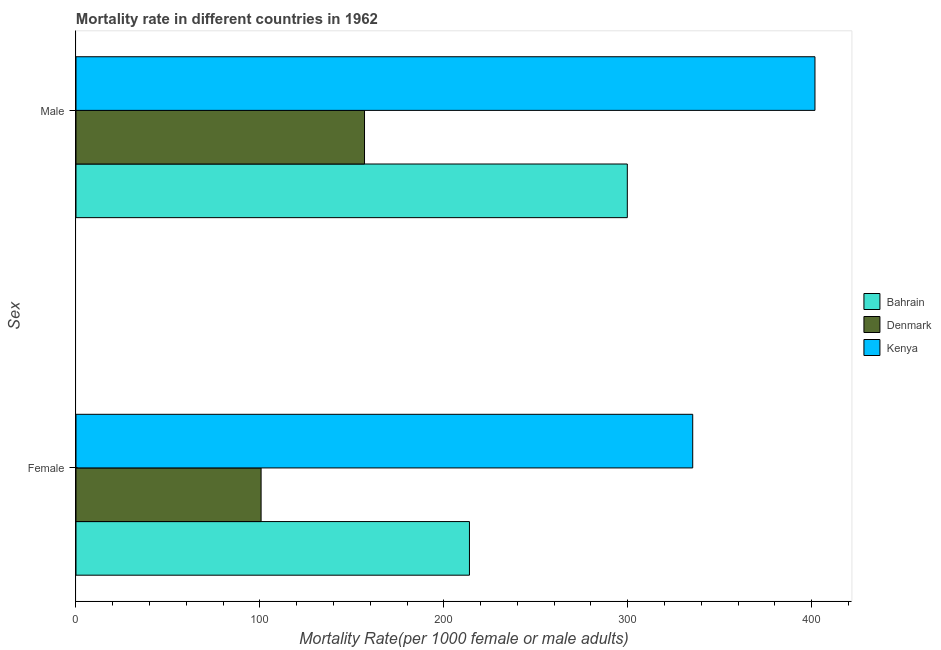Are the number of bars on each tick of the Y-axis equal?
Offer a very short reply. Yes. How many bars are there on the 2nd tick from the top?
Ensure brevity in your answer.  3. How many bars are there on the 1st tick from the bottom?
Offer a terse response. 3. What is the male mortality rate in Bahrain?
Keep it short and to the point. 299.81. Across all countries, what is the maximum male mortality rate?
Keep it short and to the point. 401.86. Across all countries, what is the minimum male mortality rate?
Your response must be concise. 156.9. In which country was the female mortality rate maximum?
Give a very brief answer. Kenya. What is the total female mortality rate in the graph?
Your answer should be compact. 650.01. What is the difference between the female mortality rate in Bahrain and that in Denmark?
Make the answer very short. 113.31. What is the difference between the female mortality rate in Denmark and the male mortality rate in Kenya?
Offer a very short reply. -301.2. What is the average male mortality rate per country?
Your response must be concise. 286.19. What is the difference between the female mortality rate and male mortality rate in Bahrain?
Offer a terse response. -85.84. In how many countries, is the female mortality rate greater than 80 ?
Your answer should be compact. 3. What is the ratio of the male mortality rate in Denmark to that in Bahrain?
Give a very brief answer. 0.52. What does the 1st bar from the top in Female represents?
Offer a terse response. Kenya. What does the 3rd bar from the bottom in Female represents?
Offer a very short reply. Kenya. How many countries are there in the graph?
Your answer should be very brief. 3. Are the values on the major ticks of X-axis written in scientific E-notation?
Provide a succinct answer. No. Does the graph contain any zero values?
Offer a very short reply. No. Where does the legend appear in the graph?
Keep it short and to the point. Center right. How many legend labels are there?
Provide a succinct answer. 3. What is the title of the graph?
Provide a short and direct response. Mortality rate in different countries in 1962. What is the label or title of the X-axis?
Offer a very short reply. Mortality Rate(per 1000 female or male adults). What is the label or title of the Y-axis?
Your answer should be very brief. Sex. What is the Mortality Rate(per 1000 female or male adults) in Bahrain in Female?
Your answer should be very brief. 213.97. What is the Mortality Rate(per 1000 female or male adults) in Denmark in Female?
Provide a short and direct response. 100.66. What is the Mortality Rate(per 1000 female or male adults) in Kenya in Female?
Make the answer very short. 335.38. What is the Mortality Rate(per 1000 female or male adults) of Bahrain in Male?
Provide a succinct answer. 299.81. What is the Mortality Rate(per 1000 female or male adults) in Denmark in Male?
Your answer should be compact. 156.9. What is the Mortality Rate(per 1000 female or male adults) in Kenya in Male?
Make the answer very short. 401.86. Across all Sex, what is the maximum Mortality Rate(per 1000 female or male adults) in Bahrain?
Your answer should be very brief. 299.81. Across all Sex, what is the maximum Mortality Rate(per 1000 female or male adults) of Denmark?
Offer a very short reply. 156.9. Across all Sex, what is the maximum Mortality Rate(per 1000 female or male adults) of Kenya?
Offer a terse response. 401.86. Across all Sex, what is the minimum Mortality Rate(per 1000 female or male adults) of Bahrain?
Your answer should be compact. 213.97. Across all Sex, what is the minimum Mortality Rate(per 1000 female or male adults) of Denmark?
Offer a very short reply. 100.66. Across all Sex, what is the minimum Mortality Rate(per 1000 female or male adults) in Kenya?
Make the answer very short. 335.38. What is the total Mortality Rate(per 1000 female or male adults) of Bahrain in the graph?
Your answer should be compact. 513.78. What is the total Mortality Rate(per 1000 female or male adults) in Denmark in the graph?
Offer a very short reply. 257.56. What is the total Mortality Rate(per 1000 female or male adults) in Kenya in the graph?
Your answer should be compact. 737.24. What is the difference between the Mortality Rate(per 1000 female or male adults) of Bahrain in Female and that in Male?
Keep it short and to the point. -85.84. What is the difference between the Mortality Rate(per 1000 female or male adults) in Denmark in Female and that in Male?
Ensure brevity in your answer.  -56.24. What is the difference between the Mortality Rate(per 1000 female or male adults) of Kenya in Female and that in Male?
Ensure brevity in your answer.  -66.48. What is the difference between the Mortality Rate(per 1000 female or male adults) in Bahrain in Female and the Mortality Rate(per 1000 female or male adults) in Denmark in Male?
Your answer should be very brief. 57.07. What is the difference between the Mortality Rate(per 1000 female or male adults) in Bahrain in Female and the Mortality Rate(per 1000 female or male adults) in Kenya in Male?
Offer a terse response. -187.89. What is the difference between the Mortality Rate(per 1000 female or male adults) of Denmark in Female and the Mortality Rate(per 1000 female or male adults) of Kenya in Male?
Your answer should be compact. -301.2. What is the average Mortality Rate(per 1000 female or male adults) in Bahrain per Sex?
Ensure brevity in your answer.  256.89. What is the average Mortality Rate(per 1000 female or male adults) in Denmark per Sex?
Your answer should be compact. 128.78. What is the average Mortality Rate(per 1000 female or male adults) of Kenya per Sex?
Your answer should be very brief. 368.62. What is the difference between the Mortality Rate(per 1000 female or male adults) in Bahrain and Mortality Rate(per 1000 female or male adults) in Denmark in Female?
Your answer should be compact. 113.31. What is the difference between the Mortality Rate(per 1000 female or male adults) in Bahrain and Mortality Rate(per 1000 female or male adults) in Kenya in Female?
Offer a terse response. -121.41. What is the difference between the Mortality Rate(per 1000 female or male adults) in Denmark and Mortality Rate(per 1000 female or male adults) in Kenya in Female?
Keep it short and to the point. -234.72. What is the difference between the Mortality Rate(per 1000 female or male adults) of Bahrain and Mortality Rate(per 1000 female or male adults) of Denmark in Male?
Ensure brevity in your answer.  142.91. What is the difference between the Mortality Rate(per 1000 female or male adults) in Bahrain and Mortality Rate(per 1000 female or male adults) in Kenya in Male?
Provide a short and direct response. -102.05. What is the difference between the Mortality Rate(per 1000 female or male adults) of Denmark and Mortality Rate(per 1000 female or male adults) of Kenya in Male?
Keep it short and to the point. -244.96. What is the ratio of the Mortality Rate(per 1000 female or male adults) of Bahrain in Female to that in Male?
Keep it short and to the point. 0.71. What is the ratio of the Mortality Rate(per 1000 female or male adults) of Denmark in Female to that in Male?
Provide a short and direct response. 0.64. What is the ratio of the Mortality Rate(per 1000 female or male adults) in Kenya in Female to that in Male?
Give a very brief answer. 0.83. What is the difference between the highest and the second highest Mortality Rate(per 1000 female or male adults) in Bahrain?
Your answer should be compact. 85.84. What is the difference between the highest and the second highest Mortality Rate(per 1000 female or male adults) of Denmark?
Provide a short and direct response. 56.24. What is the difference between the highest and the second highest Mortality Rate(per 1000 female or male adults) of Kenya?
Give a very brief answer. 66.48. What is the difference between the highest and the lowest Mortality Rate(per 1000 female or male adults) of Bahrain?
Provide a succinct answer. 85.84. What is the difference between the highest and the lowest Mortality Rate(per 1000 female or male adults) of Denmark?
Ensure brevity in your answer.  56.24. What is the difference between the highest and the lowest Mortality Rate(per 1000 female or male adults) in Kenya?
Offer a terse response. 66.48. 